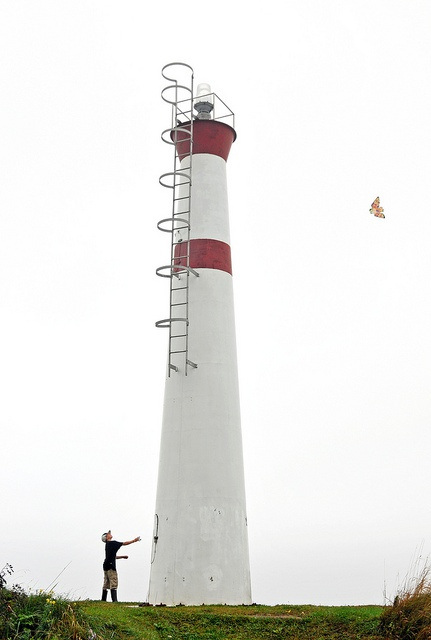Describe the objects in this image and their specific colors. I can see people in white, black, and gray tones and kite in white, tan, and lightgray tones in this image. 